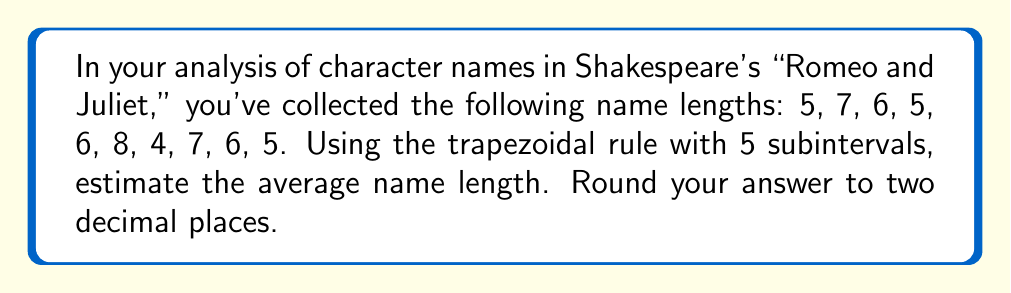What is the answer to this math problem? To solve this problem, we'll follow these steps:

1) First, we need to order the data points:
   4, 5, 5, 5, 6, 6, 6, 7, 7, 8

2) We'll use the trapezoidal rule with 5 subintervals. The formula is:

   $$\frac{b-a}{2n}[f(x_0) + 2f(x_1) + 2f(x_2) + ... + 2f(x_{n-1}) + f(x_n)]$$

   where $a$ is the first data point, $b$ is the last data point, $n$ is the number of subintervals, and $f(x_i)$ are the y-values (in this case, the frequencies).

3) We have 10 data points and 5 subintervals, so each subinterval will contain 2 data points.

4) Let's calculate the frequencies:
   4 occurs 1 time
   5 occurs 3 times
   6 occurs 3 times
   7 occurs 2 times
   8 occurs 1 time

5) Now we can apply the trapezoidal rule:

   $$\frac{8-4}{2(5)}[1 + 2(3) + 2(3) + 2(2) + 1]$$

6) Simplify:

   $$\frac{4}{10}[1 + 6 + 6 + 4 + 1]$$
   $$\frac{4}{10}[18]$$
   $$\frac{72}{10}$$
   $$7.2$$

7) The question asks for the average, so we don't need to do anything further. 7.2 rounded to two decimal places is 7.20.
Answer: 7.20 